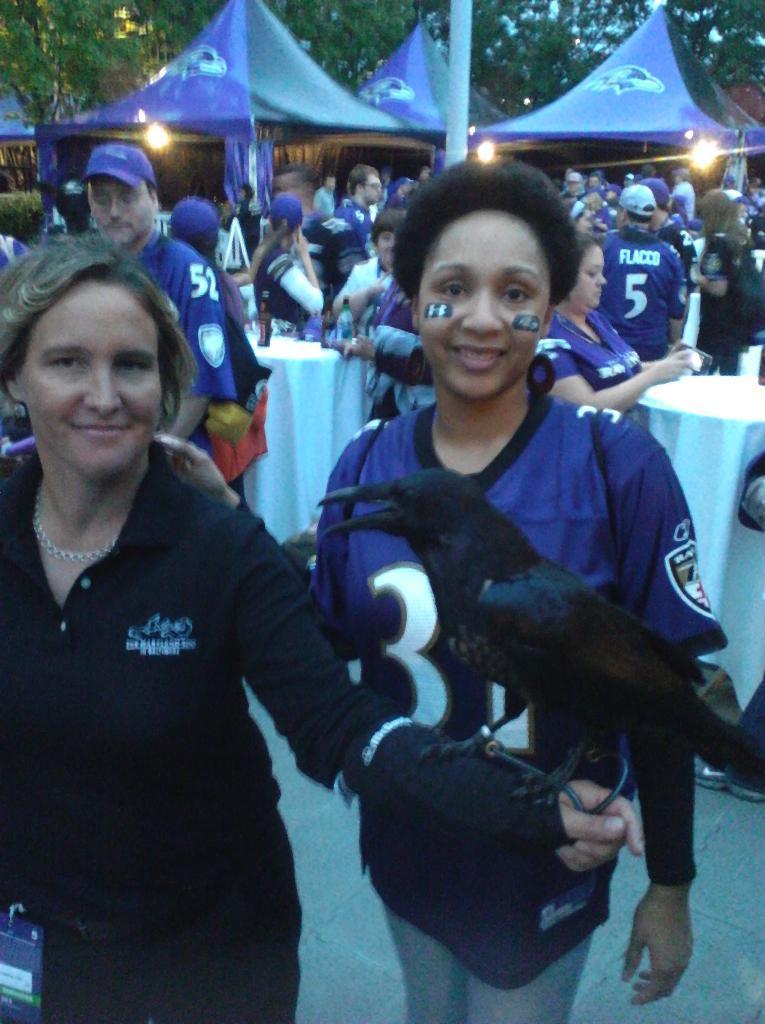In one or two sentences, can you explain what this image depicts? In this image, we can see people and some are wearing costumes and caps and there is a lady holding a bird and we can see some people wearing id cards. In the background, there are tents, lights and we can see some objects on the tables. 